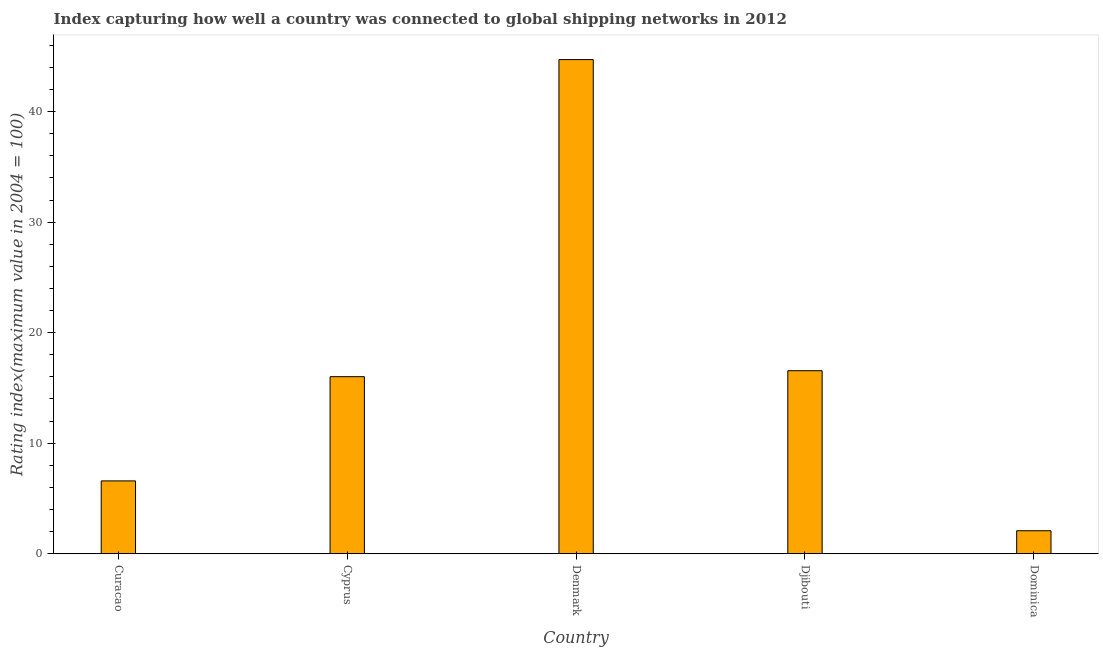Does the graph contain any zero values?
Make the answer very short. No. Does the graph contain grids?
Offer a very short reply. No. What is the title of the graph?
Offer a very short reply. Index capturing how well a country was connected to global shipping networks in 2012. What is the label or title of the X-axis?
Ensure brevity in your answer.  Country. What is the label or title of the Y-axis?
Provide a succinct answer. Rating index(maximum value in 2004 = 100). What is the liner shipping connectivity index in Cyprus?
Your response must be concise. 16.02. Across all countries, what is the maximum liner shipping connectivity index?
Give a very brief answer. 44.71. Across all countries, what is the minimum liner shipping connectivity index?
Make the answer very short. 2.08. In which country was the liner shipping connectivity index minimum?
Make the answer very short. Dominica. What is the sum of the liner shipping connectivity index?
Offer a very short reply. 85.96. What is the difference between the liner shipping connectivity index in Denmark and Dominica?
Keep it short and to the point. 42.63. What is the average liner shipping connectivity index per country?
Your answer should be compact. 17.19. What is the median liner shipping connectivity index?
Offer a terse response. 16.02. What is the ratio of the liner shipping connectivity index in Curacao to that in Denmark?
Provide a succinct answer. 0.15. Is the liner shipping connectivity index in Curacao less than that in Denmark?
Keep it short and to the point. Yes. What is the difference between the highest and the second highest liner shipping connectivity index?
Make the answer very short. 28.15. Is the sum of the liner shipping connectivity index in Denmark and Dominica greater than the maximum liner shipping connectivity index across all countries?
Ensure brevity in your answer.  Yes. What is the difference between the highest and the lowest liner shipping connectivity index?
Offer a terse response. 42.63. In how many countries, is the liner shipping connectivity index greater than the average liner shipping connectivity index taken over all countries?
Your answer should be compact. 1. How many bars are there?
Provide a short and direct response. 5. What is the Rating index(maximum value in 2004 = 100) in Curacao?
Your answer should be very brief. 6.59. What is the Rating index(maximum value in 2004 = 100) of Cyprus?
Your answer should be very brief. 16.02. What is the Rating index(maximum value in 2004 = 100) of Denmark?
Keep it short and to the point. 44.71. What is the Rating index(maximum value in 2004 = 100) of Djibouti?
Keep it short and to the point. 16.56. What is the Rating index(maximum value in 2004 = 100) of Dominica?
Offer a terse response. 2.08. What is the difference between the Rating index(maximum value in 2004 = 100) in Curacao and Cyprus?
Give a very brief answer. -9.43. What is the difference between the Rating index(maximum value in 2004 = 100) in Curacao and Denmark?
Your answer should be very brief. -38.12. What is the difference between the Rating index(maximum value in 2004 = 100) in Curacao and Djibouti?
Give a very brief answer. -9.97. What is the difference between the Rating index(maximum value in 2004 = 100) in Curacao and Dominica?
Ensure brevity in your answer.  4.51. What is the difference between the Rating index(maximum value in 2004 = 100) in Cyprus and Denmark?
Offer a very short reply. -28.69. What is the difference between the Rating index(maximum value in 2004 = 100) in Cyprus and Djibouti?
Your answer should be very brief. -0.54. What is the difference between the Rating index(maximum value in 2004 = 100) in Cyprus and Dominica?
Ensure brevity in your answer.  13.94. What is the difference between the Rating index(maximum value in 2004 = 100) in Denmark and Djibouti?
Your response must be concise. 28.15. What is the difference between the Rating index(maximum value in 2004 = 100) in Denmark and Dominica?
Your answer should be compact. 42.63. What is the difference between the Rating index(maximum value in 2004 = 100) in Djibouti and Dominica?
Provide a succinct answer. 14.48. What is the ratio of the Rating index(maximum value in 2004 = 100) in Curacao to that in Cyprus?
Provide a short and direct response. 0.41. What is the ratio of the Rating index(maximum value in 2004 = 100) in Curacao to that in Denmark?
Your answer should be very brief. 0.15. What is the ratio of the Rating index(maximum value in 2004 = 100) in Curacao to that in Djibouti?
Your answer should be very brief. 0.4. What is the ratio of the Rating index(maximum value in 2004 = 100) in Curacao to that in Dominica?
Give a very brief answer. 3.17. What is the ratio of the Rating index(maximum value in 2004 = 100) in Cyprus to that in Denmark?
Make the answer very short. 0.36. What is the ratio of the Rating index(maximum value in 2004 = 100) in Cyprus to that in Djibouti?
Ensure brevity in your answer.  0.97. What is the ratio of the Rating index(maximum value in 2004 = 100) in Cyprus to that in Dominica?
Ensure brevity in your answer.  7.7. What is the ratio of the Rating index(maximum value in 2004 = 100) in Denmark to that in Dominica?
Offer a terse response. 21.5. What is the ratio of the Rating index(maximum value in 2004 = 100) in Djibouti to that in Dominica?
Offer a very short reply. 7.96. 